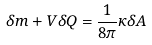<formula> <loc_0><loc_0><loc_500><loc_500>\delta m + V \delta Q = \frac { 1 } { 8 \pi } \kappa \delta A</formula> 